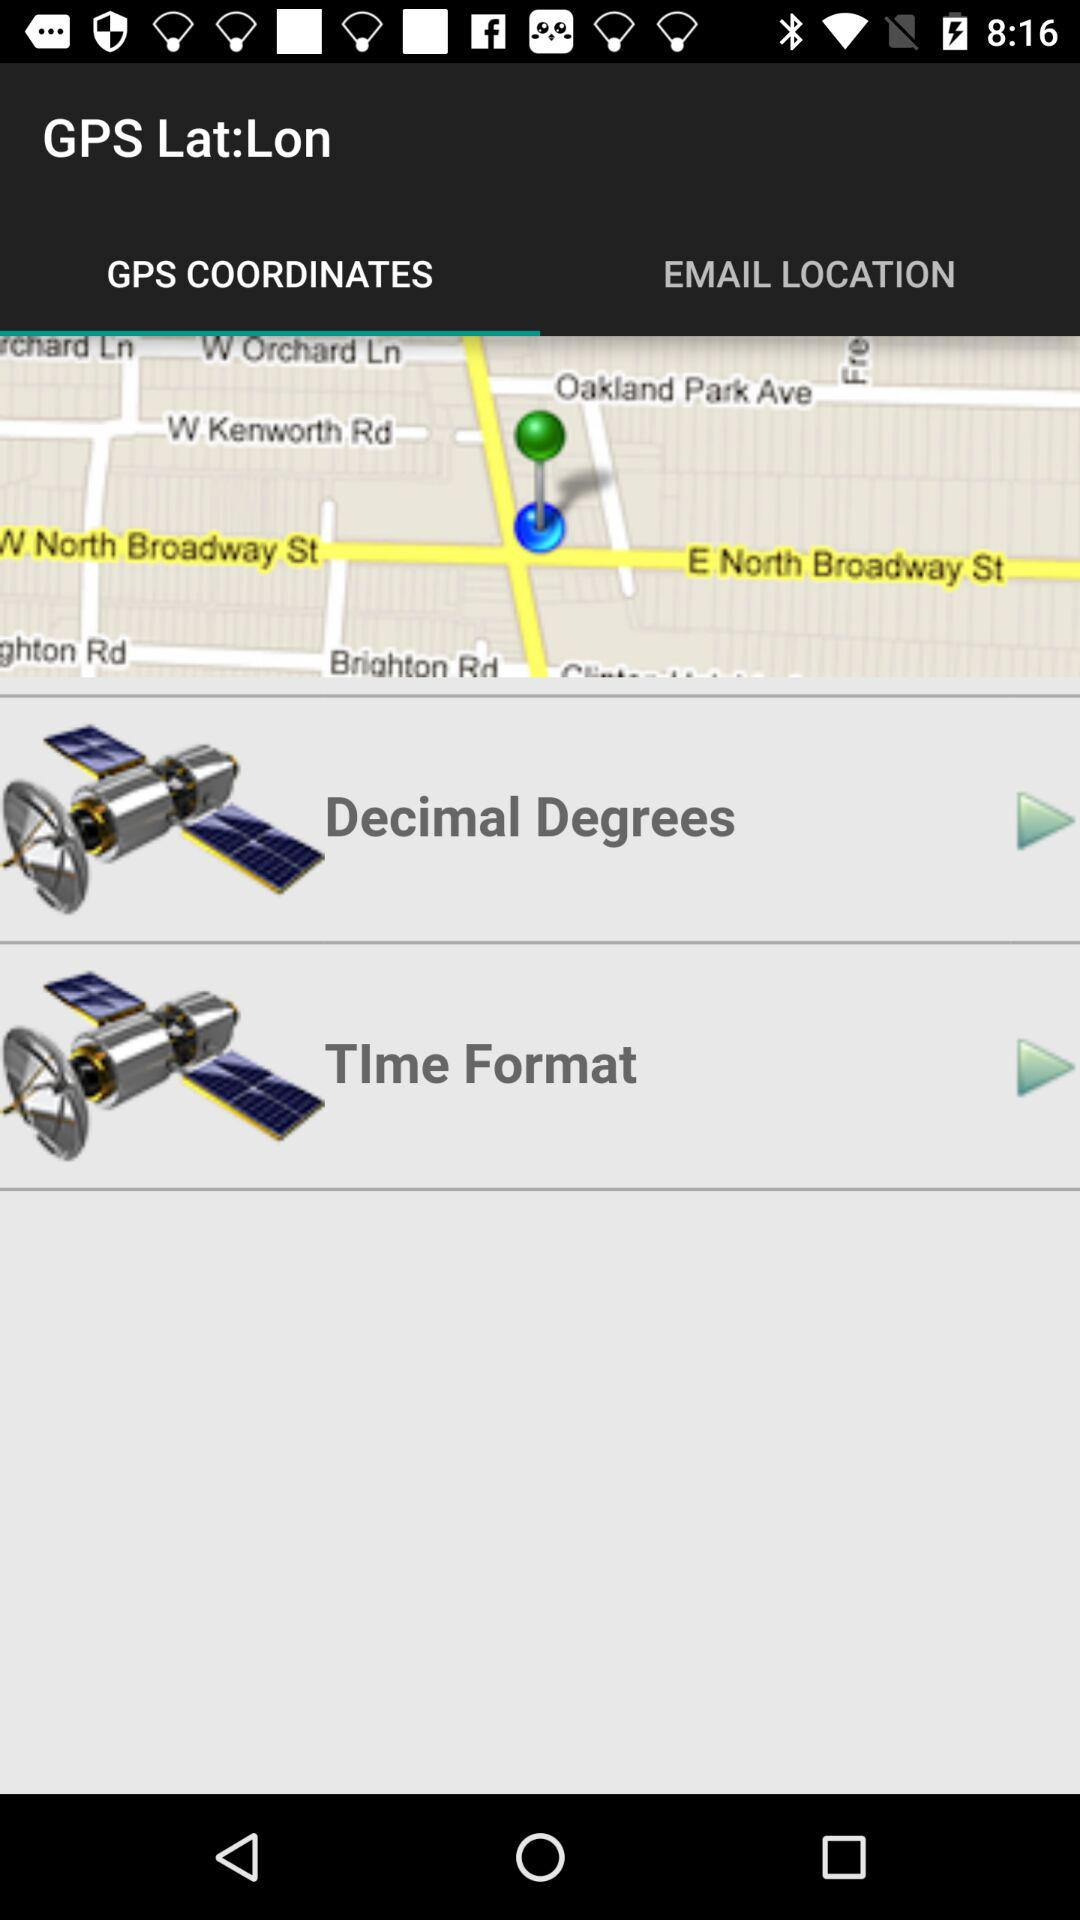Which tab is selected? The selected tab is "GPS COORDINATES". 